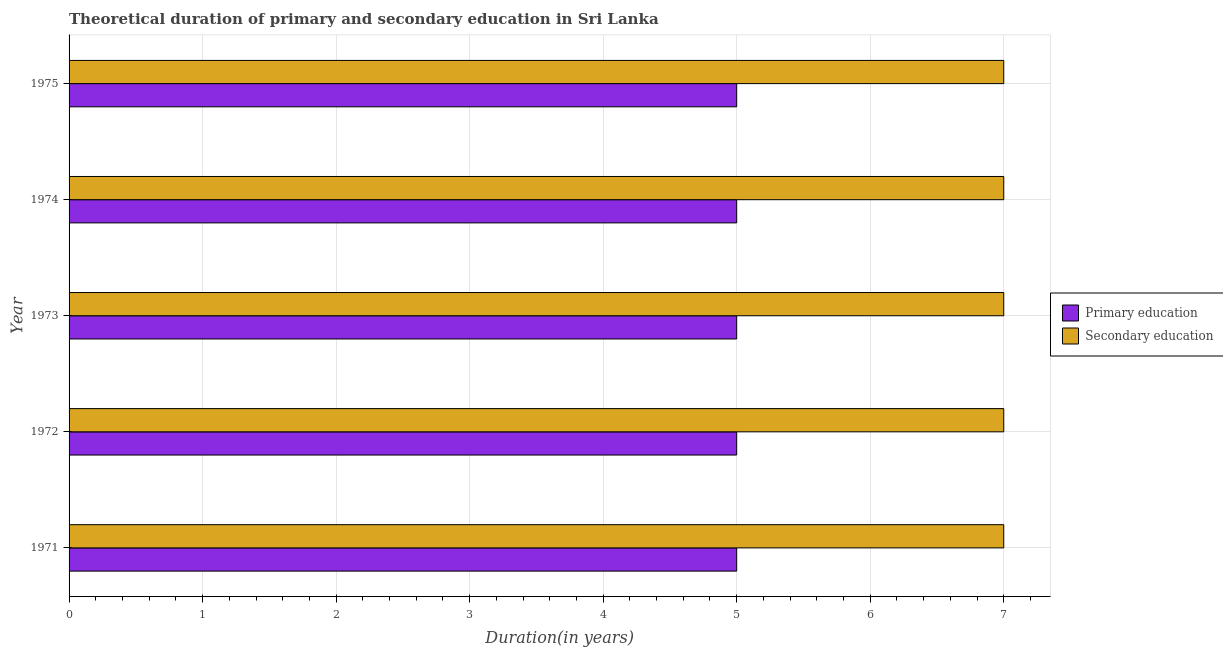How many different coloured bars are there?
Keep it short and to the point. 2. How many groups of bars are there?
Your answer should be very brief. 5. What is the duration of secondary education in 1973?
Your answer should be compact. 7. Across all years, what is the maximum duration of primary education?
Your answer should be compact. 5. Across all years, what is the minimum duration of primary education?
Keep it short and to the point. 5. In which year was the duration of secondary education maximum?
Ensure brevity in your answer.  1971. In which year was the duration of secondary education minimum?
Offer a very short reply. 1971. What is the total duration of primary education in the graph?
Offer a very short reply. 25. What is the difference between the duration of secondary education in 1972 and that in 1974?
Provide a succinct answer. 0. What is the difference between the duration of secondary education in 1972 and the duration of primary education in 1974?
Provide a succinct answer. 2. In the year 1975, what is the difference between the duration of primary education and duration of secondary education?
Give a very brief answer. -2. In how many years, is the duration of primary education greater than 2.6 years?
Give a very brief answer. 5. What is the difference between the highest and the second highest duration of primary education?
Provide a succinct answer. 0. In how many years, is the duration of primary education greater than the average duration of primary education taken over all years?
Offer a very short reply. 0. What does the 2nd bar from the bottom in 1972 represents?
Provide a short and direct response. Secondary education. How many bars are there?
Your answer should be very brief. 10. What is the difference between two consecutive major ticks on the X-axis?
Make the answer very short. 1. Are the values on the major ticks of X-axis written in scientific E-notation?
Make the answer very short. No. Does the graph contain any zero values?
Offer a terse response. No. Does the graph contain grids?
Give a very brief answer. Yes. How many legend labels are there?
Your answer should be compact. 2. How are the legend labels stacked?
Provide a succinct answer. Vertical. What is the title of the graph?
Offer a very short reply. Theoretical duration of primary and secondary education in Sri Lanka. Does "Female labourers" appear as one of the legend labels in the graph?
Keep it short and to the point. No. What is the label or title of the X-axis?
Provide a succinct answer. Duration(in years). What is the Duration(in years) of Primary education in 1971?
Your answer should be compact. 5. What is the Duration(in years) of Secondary education in 1971?
Provide a succinct answer. 7. What is the Duration(in years) of Primary education in 1972?
Your response must be concise. 5. What is the Duration(in years) in Primary education in 1974?
Your response must be concise. 5. What is the Duration(in years) in Secondary education in 1974?
Give a very brief answer. 7. What is the Duration(in years) of Secondary education in 1975?
Offer a very short reply. 7. Across all years, what is the maximum Duration(in years) of Secondary education?
Provide a short and direct response. 7. Across all years, what is the minimum Duration(in years) of Primary education?
Your response must be concise. 5. What is the total Duration(in years) in Primary education in the graph?
Offer a terse response. 25. What is the total Duration(in years) of Secondary education in the graph?
Give a very brief answer. 35. What is the difference between the Duration(in years) in Primary education in 1971 and that in 1972?
Give a very brief answer. 0. What is the difference between the Duration(in years) of Secondary education in 1971 and that in 1973?
Offer a terse response. 0. What is the difference between the Duration(in years) in Primary education in 1971 and that in 1975?
Provide a succinct answer. 0. What is the difference between the Duration(in years) of Secondary education in 1971 and that in 1975?
Make the answer very short. 0. What is the difference between the Duration(in years) of Secondary education in 1972 and that in 1973?
Offer a terse response. 0. What is the difference between the Duration(in years) in Primary education in 1972 and that in 1974?
Keep it short and to the point. 0. What is the difference between the Duration(in years) in Secondary education in 1972 and that in 1974?
Ensure brevity in your answer.  0. What is the difference between the Duration(in years) in Primary education in 1972 and that in 1975?
Keep it short and to the point. 0. What is the difference between the Duration(in years) in Secondary education in 1972 and that in 1975?
Your answer should be very brief. 0. What is the difference between the Duration(in years) in Primary education in 1973 and that in 1974?
Provide a succinct answer. 0. What is the difference between the Duration(in years) of Secondary education in 1973 and that in 1974?
Offer a very short reply. 0. What is the difference between the Duration(in years) in Secondary education in 1973 and that in 1975?
Make the answer very short. 0. What is the difference between the Duration(in years) in Primary education in 1974 and that in 1975?
Offer a very short reply. 0. What is the difference between the Duration(in years) of Secondary education in 1974 and that in 1975?
Offer a terse response. 0. What is the difference between the Duration(in years) in Primary education in 1971 and the Duration(in years) in Secondary education in 1972?
Provide a short and direct response. -2. What is the difference between the Duration(in years) in Primary education in 1971 and the Duration(in years) in Secondary education in 1974?
Your answer should be very brief. -2. What is the difference between the Duration(in years) in Primary education in 1971 and the Duration(in years) in Secondary education in 1975?
Offer a terse response. -2. What is the difference between the Duration(in years) of Primary education in 1972 and the Duration(in years) of Secondary education in 1975?
Your answer should be compact. -2. What is the difference between the Duration(in years) of Primary education in 1973 and the Duration(in years) of Secondary education in 1974?
Your answer should be compact. -2. What is the difference between the Duration(in years) in Primary education in 1973 and the Duration(in years) in Secondary education in 1975?
Your answer should be compact. -2. What is the difference between the Duration(in years) in Primary education in 1974 and the Duration(in years) in Secondary education in 1975?
Keep it short and to the point. -2. In the year 1971, what is the difference between the Duration(in years) of Primary education and Duration(in years) of Secondary education?
Keep it short and to the point. -2. What is the ratio of the Duration(in years) of Secondary education in 1971 to that in 1972?
Provide a succinct answer. 1. What is the ratio of the Duration(in years) of Primary education in 1971 to that in 1973?
Make the answer very short. 1. What is the ratio of the Duration(in years) in Primary education in 1971 to that in 1974?
Give a very brief answer. 1. What is the ratio of the Duration(in years) in Secondary education in 1971 to that in 1974?
Make the answer very short. 1. What is the ratio of the Duration(in years) of Secondary education in 1971 to that in 1975?
Your response must be concise. 1. What is the ratio of the Duration(in years) of Primary education in 1972 to that in 1973?
Keep it short and to the point. 1. What is the ratio of the Duration(in years) of Secondary education in 1972 to that in 1973?
Give a very brief answer. 1. What is the ratio of the Duration(in years) in Secondary education in 1972 to that in 1974?
Your answer should be compact. 1. What is the ratio of the Duration(in years) of Secondary education in 1973 to that in 1974?
Keep it short and to the point. 1. What is the ratio of the Duration(in years) of Primary education in 1973 to that in 1975?
Provide a succinct answer. 1. What is the ratio of the Duration(in years) in Secondary education in 1973 to that in 1975?
Provide a short and direct response. 1. What is the ratio of the Duration(in years) in Primary education in 1974 to that in 1975?
Your answer should be compact. 1. What is the difference between the highest and the second highest Duration(in years) in Primary education?
Keep it short and to the point. 0. What is the difference between the highest and the second highest Duration(in years) in Secondary education?
Your response must be concise. 0. 